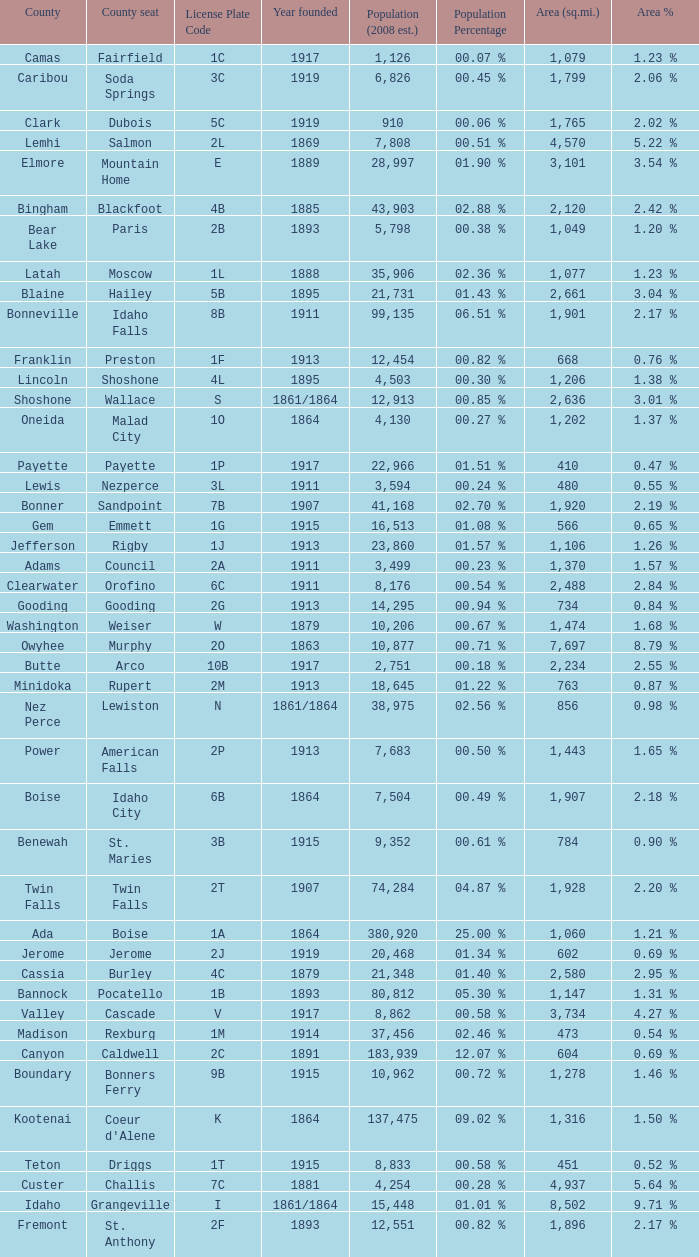What is the license plate code for the country with an area of 784? 3B. 